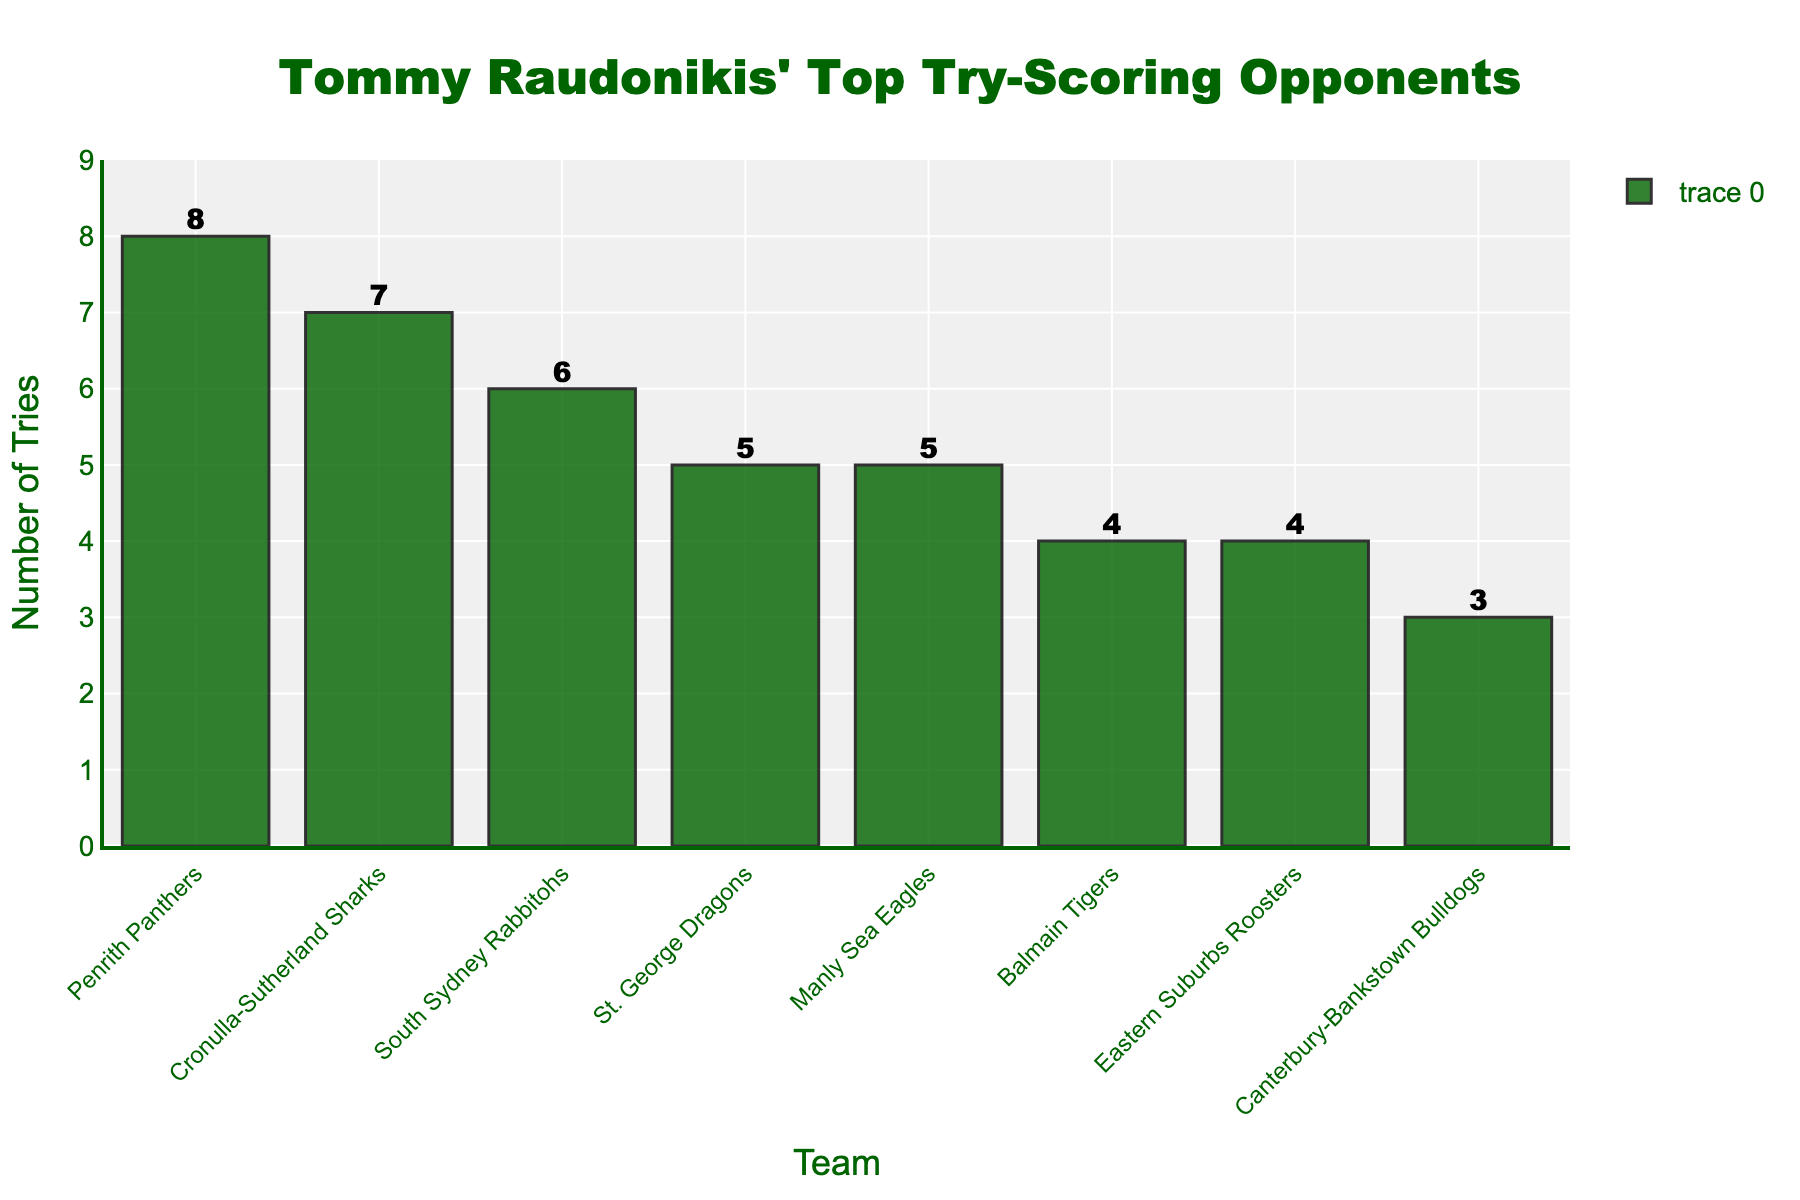What is the number of tries Tommy Raudonikis scored against the Cronulla-Sutherland Sharks? By examining the chart, we find the bar labeled "Cronulla-Sutherland Sharks". The value on top of the bar indicates the number of tries scored.
Answer: 7 Which team did Tommy Raudonikis score the most tries against? By locating the tallest bar in the chart, we identify the team represented by that bar, which indicates the team against which the most tries were scored.
Answer: Penrith Panthers How many more tries did Tommy Raudonikis score against the Penrith Panthers compared to the Manly Sea Eagles? First, identify the number of tries scored against each team from the chart (Penrith Panthers: 8, Manly Sea Eagles: 5). Then, subtract the latter from the former: 8 - 5.
Answer: 3 What is the average number of tries Tommy Raudonikis scored against the top 3 teams? Identify the top 3 bars (Penrith Panthers: 8, Cronulla-Sutherland Sharks: 7, South Sydney Rabbitohs: 6). Sum these values (8 + 7 + 6 = 21) and divide by 3.
Answer: 7 Compare the number of tries scored against the South Sydney Rabbitohs with the St. George Dragons. Which team has a higher count and by how much? Identify the number of tries scored against each team from the chart (South Sydney Rabbitohs: 6, St. George Dragons: 5). Then, subtract the lower count from the higher count: 6 - 5.
Answer: South Sydney Rabbitohs by 1 What is the total number of tries scored against the top 5 teams? Identify the number of tries scored against each of the top 5 teams and sum them: 8 (Penrith Panthers) + 7 (Cronulla-Sutherland Sharks) + 6 (South Sydney Rabbitohs) + 5 (St. George Dragons) + 5 (Manly Sea Eagles). The total sum is 31.
Answer: 31 How many teams did Tommy Raudonikis score exactly 5 tries against? Identify the bars that have a value of 5 from the chart. There are two teams: St. George Dragons and Manly Sea Eagles.
Answer: 2 teams Is there any team Tommy Raudonikis scored an equal number of tries against? If yes, which teams and how many tries? Identify bars with identical heights to find teams with the same number of tries scored. The Manly Sea Eagles and St. George Dragons both have 5 tries, and the Balmain Tigers and Eastern Suburbs Roosters both have 4 tries.
Answer: Yes, St. George Dragons and Manly Sea Eagles (5); Balmain Tigers and Eastern Suburbs Roosters (4) What is the sum of tries scored against teams that are not in the top 5? Identify the number of tries scored against the teams not in the top 5 (Balmain Tigers: 4; Eastern Suburbs Roosters: 4; Canterbury-Bankstown Bulldogs: 3). Sum these values: 4 + 4 + 3 = 11.
Answer: 11 Which team's bar color is used in the chart, and what other color features do the bars have? The bars are colored dark green and have black outlines.
Answer: Dark green with black outlines 